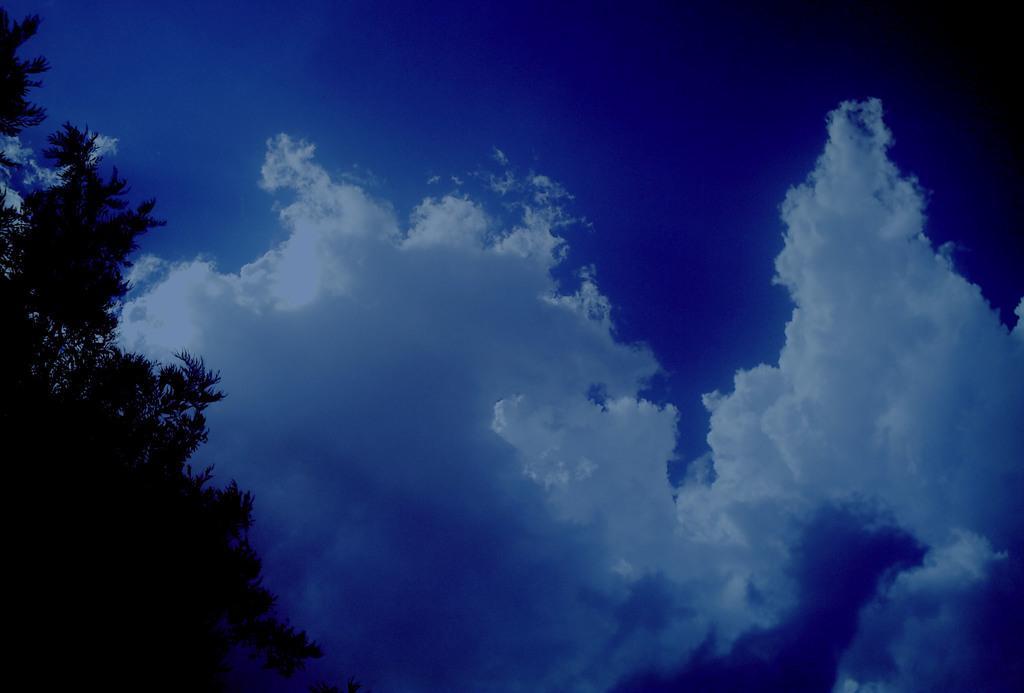Describe this image in one or two sentences. These are the clouds in the sky. On the left side of the image, I can see a tree with branches and leaves. 